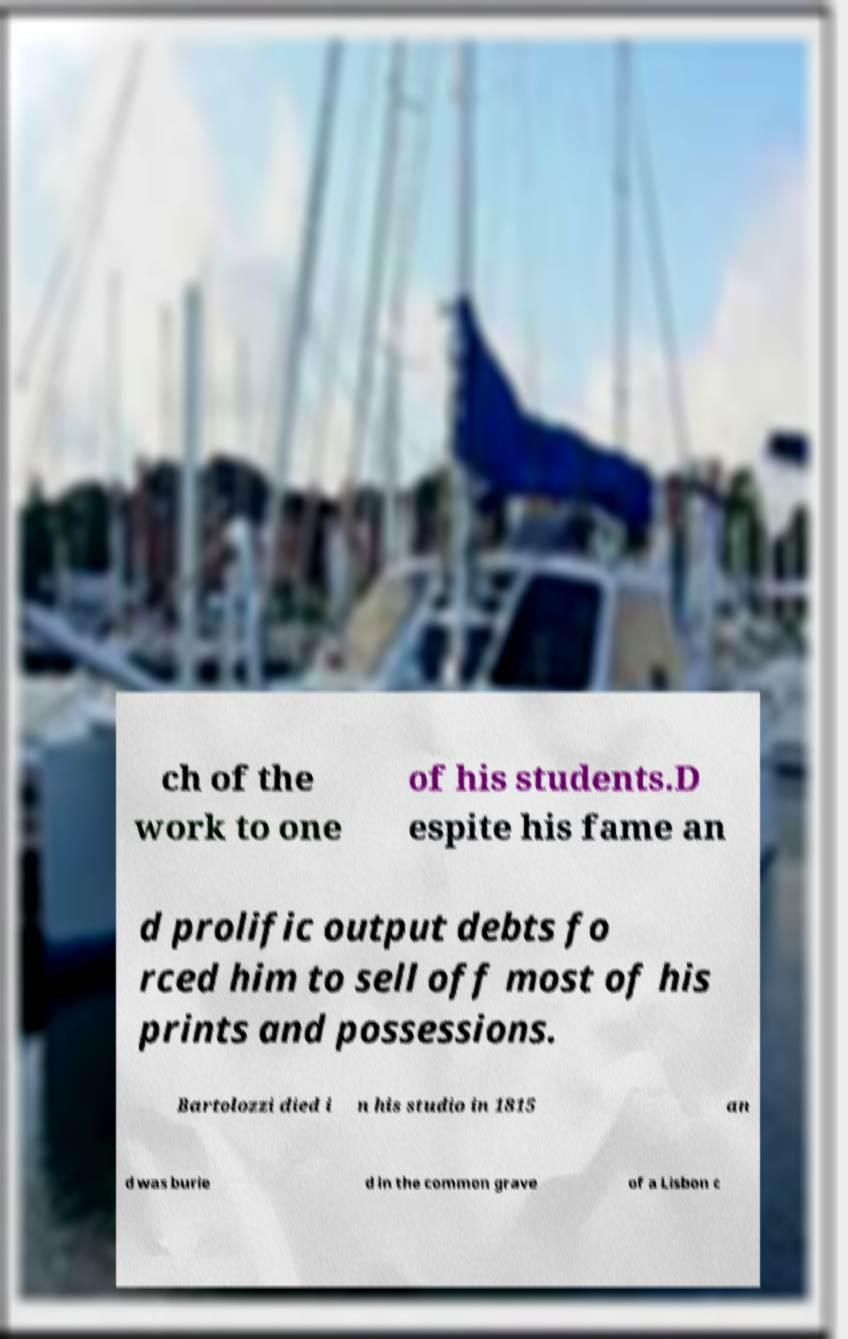Could you extract and type out the text from this image? ch of the work to one of his students.D espite his fame an d prolific output debts fo rced him to sell off most of his prints and possessions. Bartolozzi died i n his studio in 1815 an d was burie d in the common grave of a Lisbon c 